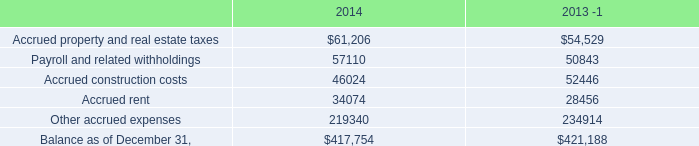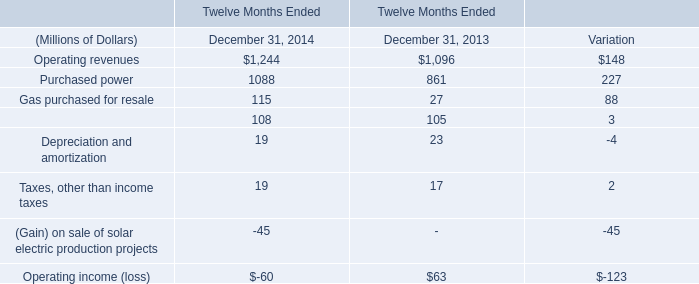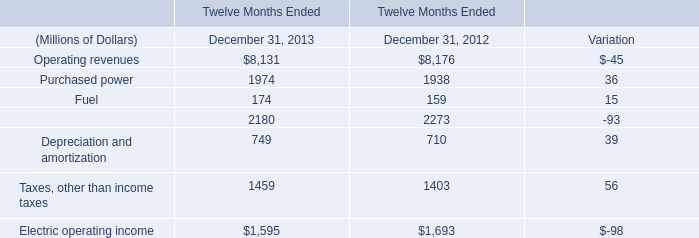What is the sum of Payroll and related withholdings of 2014, and Electric operating income of Twelve Months Ended December 31, 2013 ? 
Computations: (57110.0 + 1595.0)
Answer: 58705.0. 